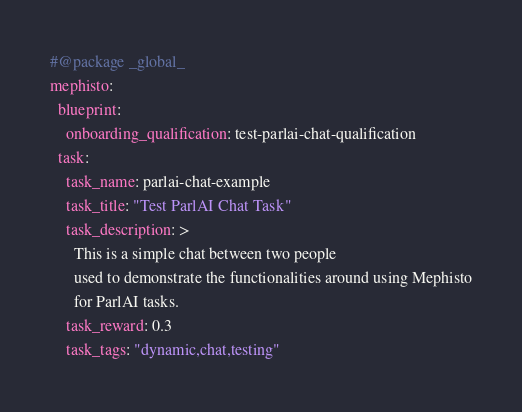Convert code to text. <code><loc_0><loc_0><loc_500><loc_500><_YAML_>#@package _global_
mephisto:
  blueprint:
    onboarding_qualification: test-parlai-chat-qualification
  task:
    task_name: parlai-chat-example
    task_title: "Test ParlAI Chat Task"
    task_description: >
      This is a simple chat between two people
      used to demonstrate the functionalities around using Mephisto
      for ParlAI tasks.
    task_reward: 0.3
    task_tags: "dynamic,chat,testing"
</code> 